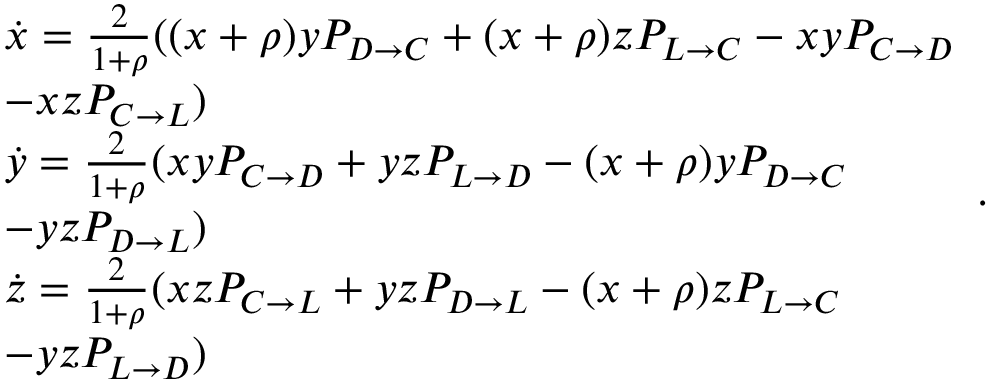<formula> <loc_0><loc_0><loc_500><loc_500>\begin{array} { l } { \dot { x } = \frac { 2 } { 1 + \rho } ( ( x + \rho ) y P _ { D \to C } + ( x + \rho ) z P _ { L \to C } - x y P _ { C \to D } } \\ { - x z P _ { C \to L } ) } \\ { \dot { y } = \frac { 2 } { 1 + \rho } ( x y P _ { C \to D } + y z P _ { L \to D } - ( x + \rho ) y P _ { D \to C } } \\ { - y z P _ { D \to L } ) } \\ { \dot { z } = \frac { 2 } { 1 + \rho } ( x z P _ { C \to L } + y z P _ { D \to L } - ( x + \rho ) z P _ { L \to C } } \\ { - y z P _ { L \to D } ) } \end{array} .</formula> 